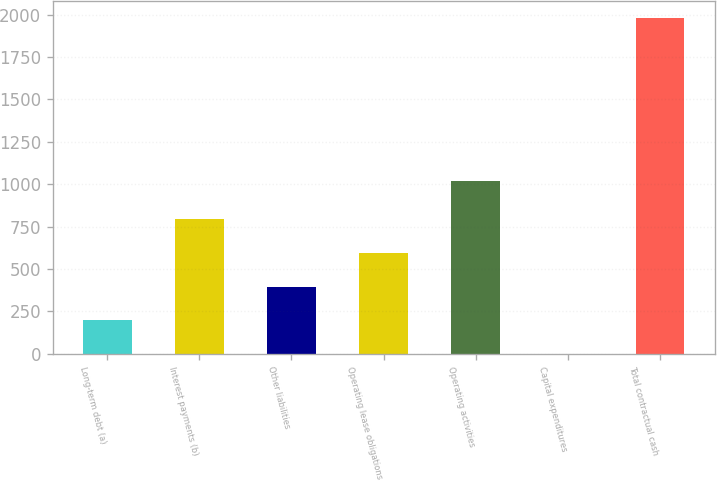<chart> <loc_0><loc_0><loc_500><loc_500><bar_chart><fcel>Long-term debt (a)<fcel>Interest payments (b)<fcel>Other liabilities<fcel>Operating lease obligations<fcel>Operating activities<fcel>Capital expenditures<fcel>Total contractual cash<nl><fcel>199.1<fcel>793.4<fcel>397.2<fcel>595.3<fcel>1017<fcel>1<fcel>1982<nl></chart> 